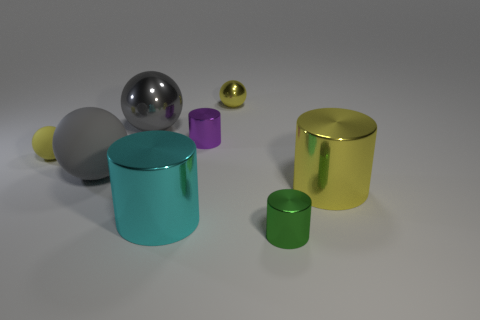Is there a small yellow metallic object of the same shape as the purple thing?
Your answer should be very brief. No. What is the material of the big yellow object?
Ensure brevity in your answer.  Metal. There is a large cyan metallic cylinder; are there any big yellow objects in front of it?
Provide a succinct answer. No. How many gray objects are behind the big gray sphere that is in front of the large gray metal sphere?
Provide a short and direct response. 1. What is the material of the ball that is the same size as the yellow rubber thing?
Offer a terse response. Metal. How many other things are there of the same material as the purple thing?
Ensure brevity in your answer.  5. There is a yellow rubber ball; what number of large gray balls are on the left side of it?
Make the answer very short. 0. What number of balls are either yellow matte things or cyan things?
Offer a very short reply. 1. How big is the yellow thing that is on the left side of the green metallic cylinder and right of the small rubber object?
Make the answer very short. Small. How many other things are there of the same color as the large matte ball?
Provide a short and direct response. 1. 